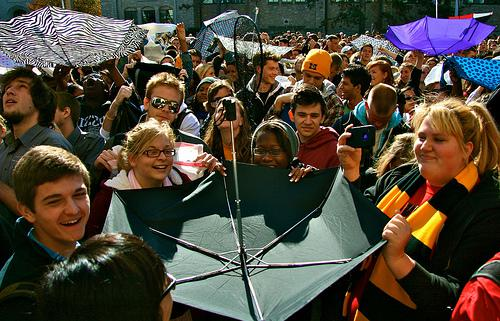Question: what is the picture showing?
Choices:
A. People in a crowd.
B. Family.
C. Dog.
D. Elephant.
Answer with the letter. Answer: A Question: what are the people doing?
Choices:
A. Holding the umbrella upside down.
B. Running.
C. Walking.
D. Laughing.
Answer with the letter. Answer: A Question: when was the picture taken?
Choices:
A. Morning.
B. Afternoon.
C. During the day.
D. Evening.
Answer with the letter. Answer: C Question: how many umbrella can be seen in the picture?
Choices:
A. One.
B. Two.
C. Seven.
D. None.
Answer with the letter. Answer: C Question: where was the picture taken?
Choices:
A. Zoo.
B. House.
C. In a crowd of people.
D. Field.
Answer with the letter. Answer: C 